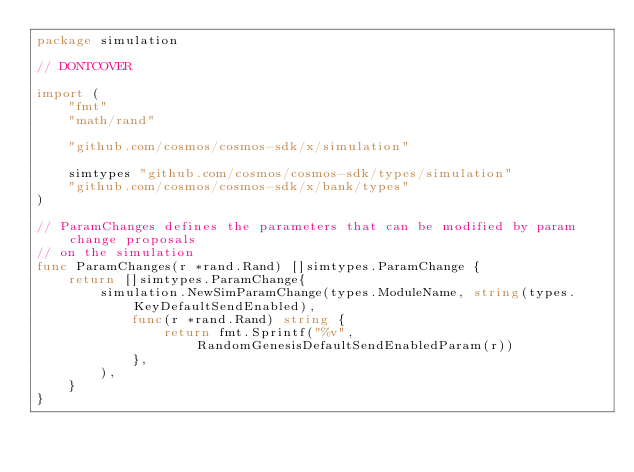Convert code to text. <code><loc_0><loc_0><loc_500><loc_500><_Go_>package simulation

// DONTCOVER

import (
	"fmt"
	"math/rand"

	"github.com/cosmos/cosmos-sdk/x/simulation"

	simtypes "github.com/cosmos/cosmos-sdk/types/simulation"
	"github.com/cosmos/cosmos-sdk/x/bank/types"
)

// ParamChanges defines the parameters that can be modified by param change proposals
// on the simulation
func ParamChanges(r *rand.Rand) []simtypes.ParamChange {
	return []simtypes.ParamChange{
		simulation.NewSimParamChange(types.ModuleName, string(types.KeyDefaultSendEnabled),
			func(r *rand.Rand) string {
				return fmt.Sprintf("%v", RandomGenesisDefaultSendEnabledParam(r))
			},
		),
	}
}
</code> 